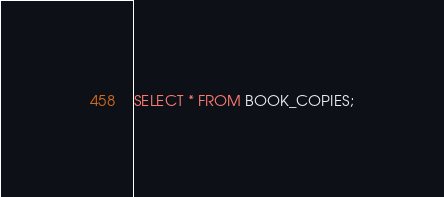<code> <loc_0><loc_0><loc_500><loc_500><_SQL_>SELECT * FROM BOOK_COPIES;</code> 